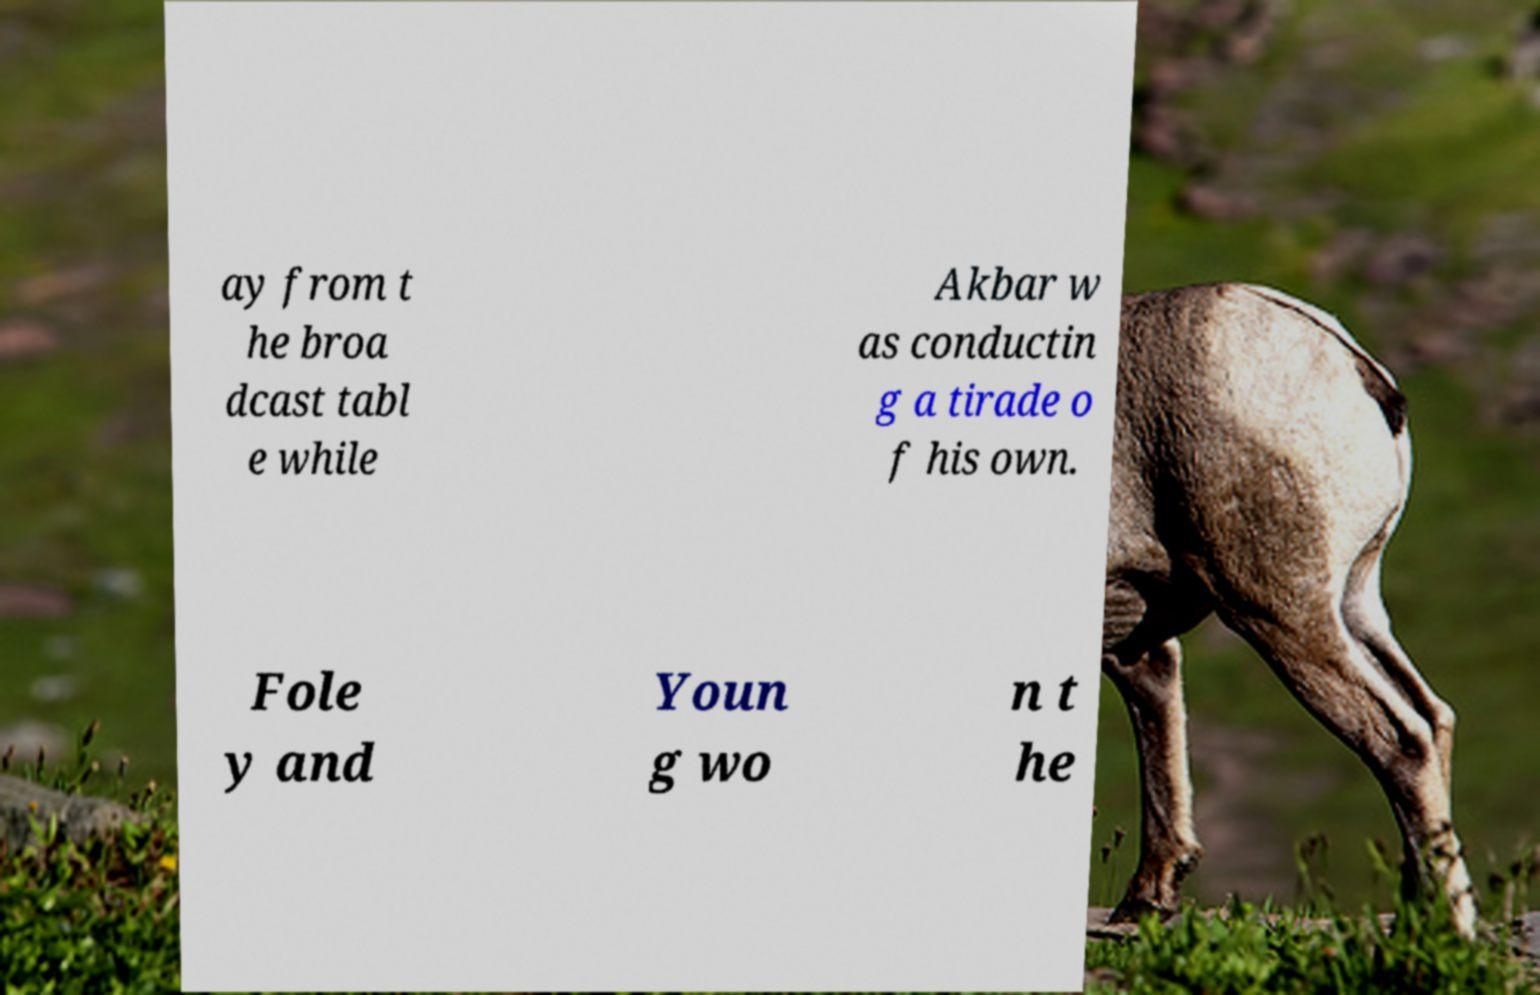Please read and relay the text visible in this image. What does it say? ay from t he broa dcast tabl e while Akbar w as conductin g a tirade o f his own. Fole y and Youn g wo n t he 